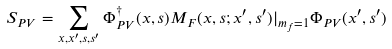Convert formula to latex. <formula><loc_0><loc_0><loc_500><loc_500>S _ { P V } = \sum _ { x , x ^ { \prime } , s , s ^ { \prime } } \Phi _ { P V } ^ { \dagger } ( x , s ) M _ { F } ( x , s ; x ^ { \prime } , s ^ { \prime } ) | _ { m _ { f } = 1 } \Phi _ { P V } ( x ^ { \prime } , s ^ { \prime } )</formula> 